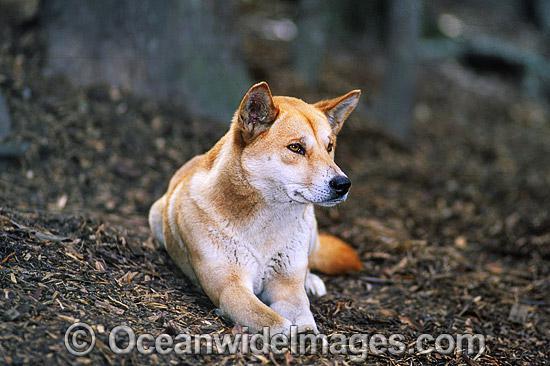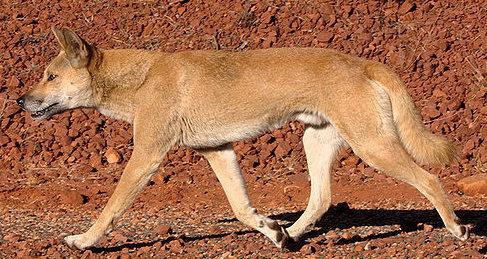The first image is the image on the left, the second image is the image on the right. For the images displayed, is the sentence "A dingo is walking on red dirt in one image." factually correct? Answer yes or no. Yes. The first image is the image on the left, the second image is the image on the right. Assess this claim about the two images: "In at least one image a lone dog on a red sand surface". Correct or not? Answer yes or no. Yes. 